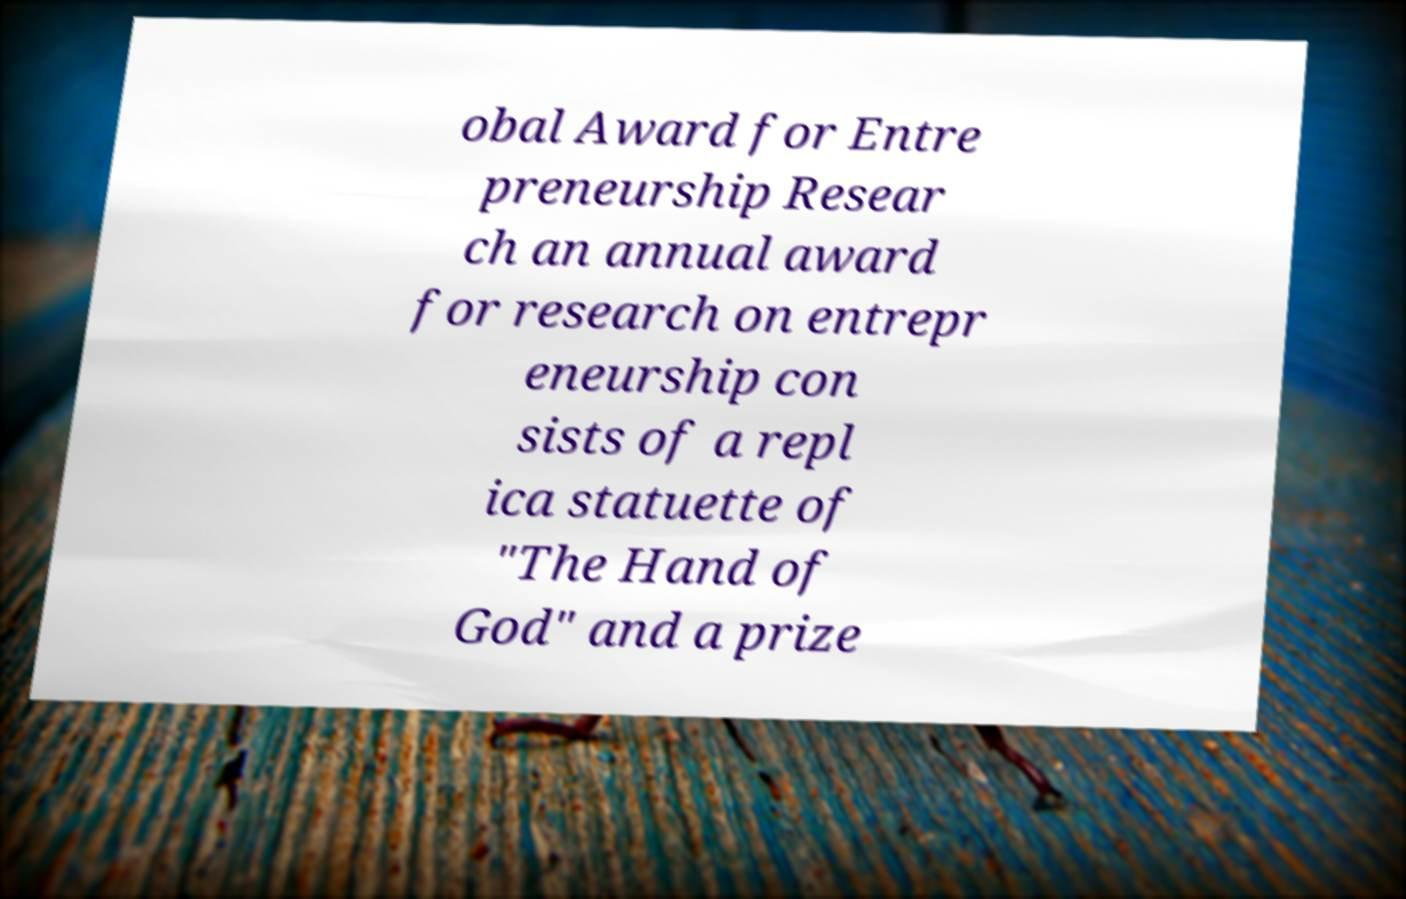For documentation purposes, I need the text within this image transcribed. Could you provide that? obal Award for Entre preneurship Resear ch an annual award for research on entrepr eneurship con sists of a repl ica statuette of "The Hand of God" and a prize 